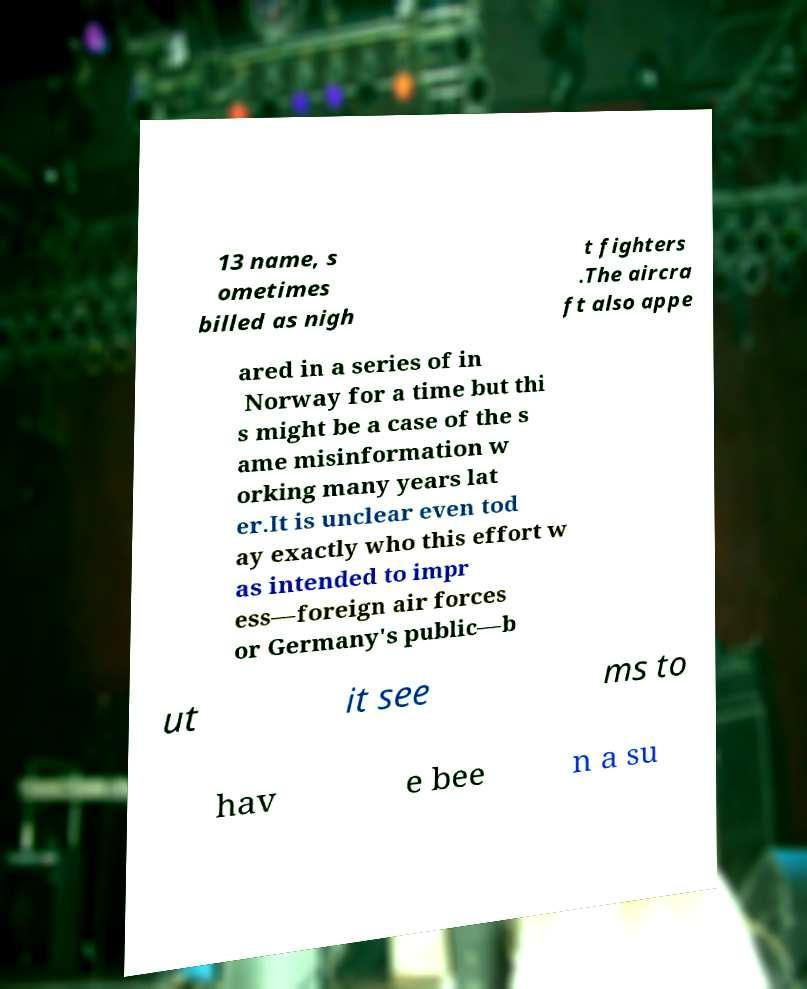What messages or text are displayed in this image? I need them in a readable, typed format. 13 name, s ometimes billed as nigh t fighters .The aircra ft also appe ared in a series of in Norway for a time but thi s might be a case of the s ame misinformation w orking many years lat er.It is unclear even tod ay exactly who this effort w as intended to impr ess—foreign air forces or Germany's public—b ut it see ms to hav e bee n a su 